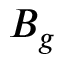Convert formula to latex. <formula><loc_0><loc_0><loc_500><loc_500>B _ { g }</formula> 